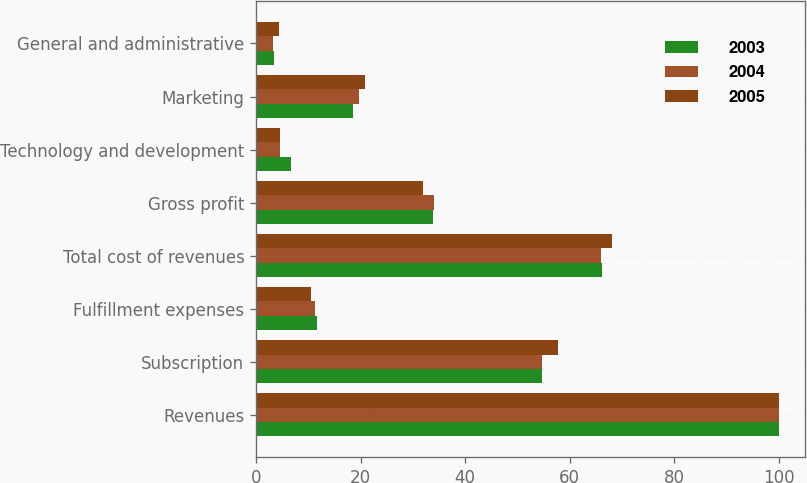Convert chart. <chart><loc_0><loc_0><loc_500><loc_500><stacked_bar_chart><ecel><fcel>Revenues<fcel>Subscription<fcel>Fulfillment expenses<fcel>Total cost of revenues<fcel>Gross profit<fcel>Technology and development<fcel>Marketing<fcel>General and administrative<nl><fcel>2003<fcel>100<fcel>54.6<fcel>11.6<fcel>66.2<fcel>33.8<fcel>6.6<fcel>18.5<fcel>3.5<nl><fcel>2004<fcel>100<fcel>54.6<fcel>11.3<fcel>65.9<fcel>34.1<fcel>4.6<fcel>19.6<fcel>3.3<nl><fcel>2005<fcel>100<fcel>57.7<fcel>10.4<fcel>68.1<fcel>31.9<fcel>4.5<fcel>20.8<fcel>4.3<nl></chart> 